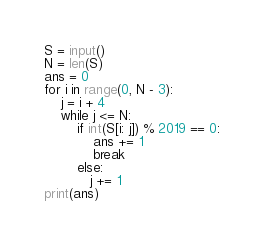<code> <loc_0><loc_0><loc_500><loc_500><_Python_>S = input()
N = len(S)
ans = 0
for i in range(0, N - 3):
    j = i + 4
    while j <= N:
        if int(S[i: j]) % 2019 == 0:
            ans += 1
            break
        else:
           j += 1
print(ans)</code> 